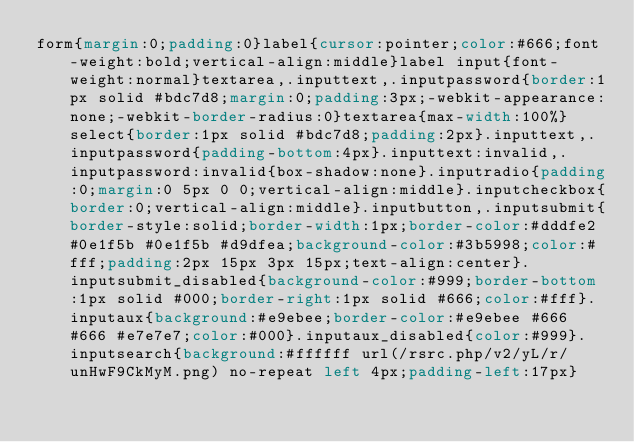<code> <loc_0><loc_0><loc_500><loc_500><_CSS_>form{margin:0;padding:0}label{cursor:pointer;color:#666;font-weight:bold;vertical-align:middle}label input{font-weight:normal}textarea,.inputtext,.inputpassword{border:1px solid #bdc7d8;margin:0;padding:3px;-webkit-appearance:none;-webkit-border-radius:0}textarea{max-width:100%}select{border:1px solid #bdc7d8;padding:2px}.inputtext,.inputpassword{padding-bottom:4px}.inputtext:invalid,.inputpassword:invalid{box-shadow:none}.inputradio{padding:0;margin:0 5px 0 0;vertical-align:middle}.inputcheckbox{border:0;vertical-align:middle}.inputbutton,.inputsubmit{border-style:solid;border-width:1px;border-color:#dddfe2 #0e1f5b #0e1f5b #d9dfea;background-color:#3b5998;color:#fff;padding:2px 15px 3px 15px;text-align:center}.inputsubmit_disabled{background-color:#999;border-bottom:1px solid #000;border-right:1px solid #666;color:#fff}.inputaux{background:#e9ebee;border-color:#e9ebee #666 #666 #e7e7e7;color:#000}.inputaux_disabled{color:#999}.inputsearch{background:#ffffff url(/rsrc.php/v2/yL/r/unHwF9CkMyM.png) no-repeat left 4px;padding-left:17px}</code> 